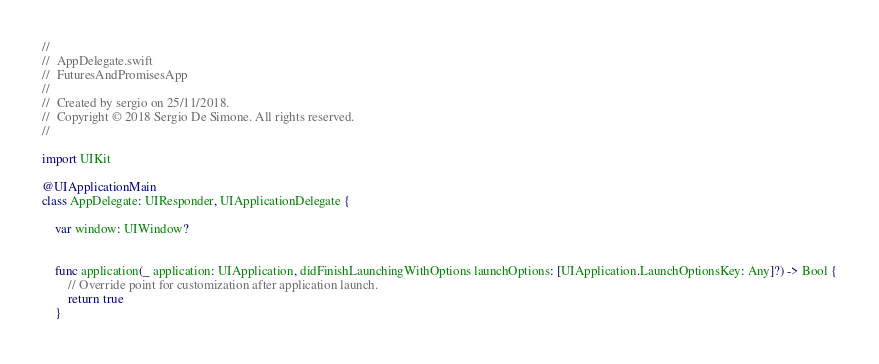Convert code to text. <code><loc_0><loc_0><loc_500><loc_500><_Swift_>//
//  AppDelegate.swift
//  FuturesAndPromisesApp
//
//  Created by sergio on 25/11/2018.
//  Copyright © 2018 Sergio De Simone. All rights reserved.
//

import UIKit

@UIApplicationMain
class AppDelegate: UIResponder, UIApplicationDelegate {

    var window: UIWindow?


    func application(_ application: UIApplication, didFinishLaunchingWithOptions launchOptions: [UIApplication.LaunchOptionsKey: Any]?) -> Bool {
        // Override point for customization after application launch.
        return true
    }
</code> 